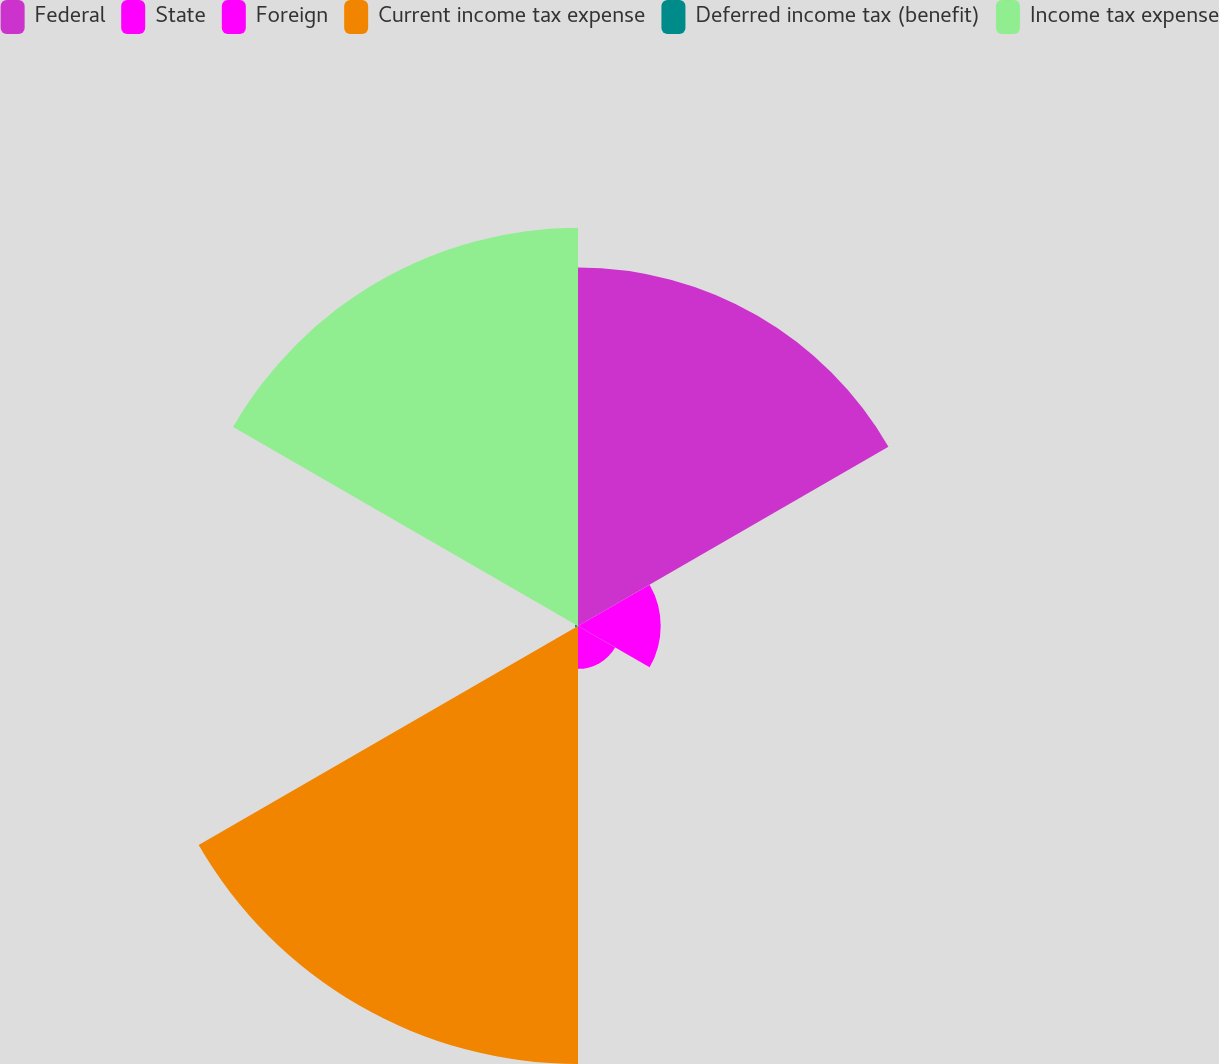<chart> <loc_0><loc_0><loc_500><loc_500><pie_chart><fcel>Federal<fcel>State<fcel>Foreign<fcel>Current income tax expense<fcel>Deferred income tax (benefit)<fcel>Income tax expense<nl><fcel>27.09%<fcel>6.25%<fcel>3.24%<fcel>33.1%<fcel>0.23%<fcel>30.09%<nl></chart> 